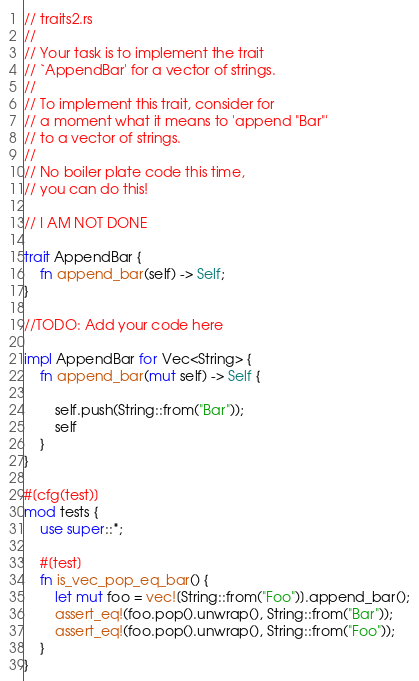<code> <loc_0><loc_0><loc_500><loc_500><_Rust_>// traits2.rs
//
// Your task is to implement the trait
// `AppendBar' for a vector of strings.
//
// To implement this trait, consider for
// a moment what it means to 'append "Bar"'
// to a vector of strings.
//
// No boiler plate code this time,
// you can do this!

// I AM NOT DONE

trait AppendBar {
    fn append_bar(self) -> Self;
}

//TODO: Add your code here

impl AppendBar for Vec<String> {
    fn append_bar(mut self) -> Self {
        
        self.push(String::from("Bar"));
        self
    }
}

#[cfg(test)]
mod tests {
    use super::*;

    #[test]
    fn is_vec_pop_eq_bar() {
        let mut foo = vec![String::from("Foo")].append_bar();
        assert_eq!(foo.pop().unwrap(), String::from("Bar"));
        assert_eq!(foo.pop().unwrap(), String::from("Foo"));
    }
}
</code> 